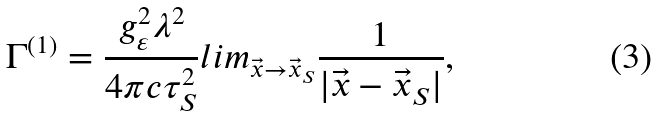Convert formula to latex. <formula><loc_0><loc_0><loc_500><loc_500>\Gamma ^ { ( 1 ) } = \frac { g _ { \varepsilon } ^ { 2 } \lambda ^ { 2 } } { 4 \pi c \tau _ { S } ^ { 2 } } l i m _ { \vec { x } \rightarrow \vec { x } _ { S } } \frac { 1 } { | \vec { x } - \vec { x } _ { S } | } ,</formula> 